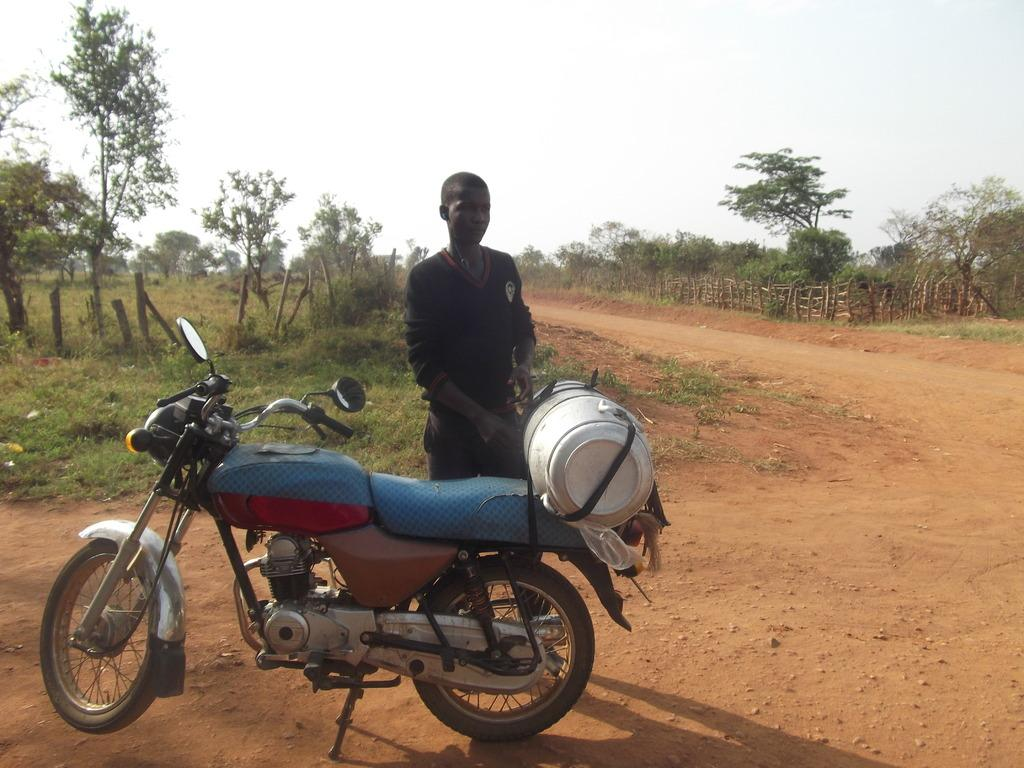What is the main subject of the image? There is a man standing in the image. What is the man wearing? The man is wearing clothes. What object is in front of the man? There is a bike in front of the man. What type of terrain is visible in the image? There is sand and grass visible in the image. What structures are present in the image? There is a pole, a plant, trees, and a wooden fence in the image. What is the color of the sky in the image? The sky is white in the image. How many cans of paint does the man have in the image? There is no mention of cans of paint in the image; the man is simply standing with a bike in front of him. 